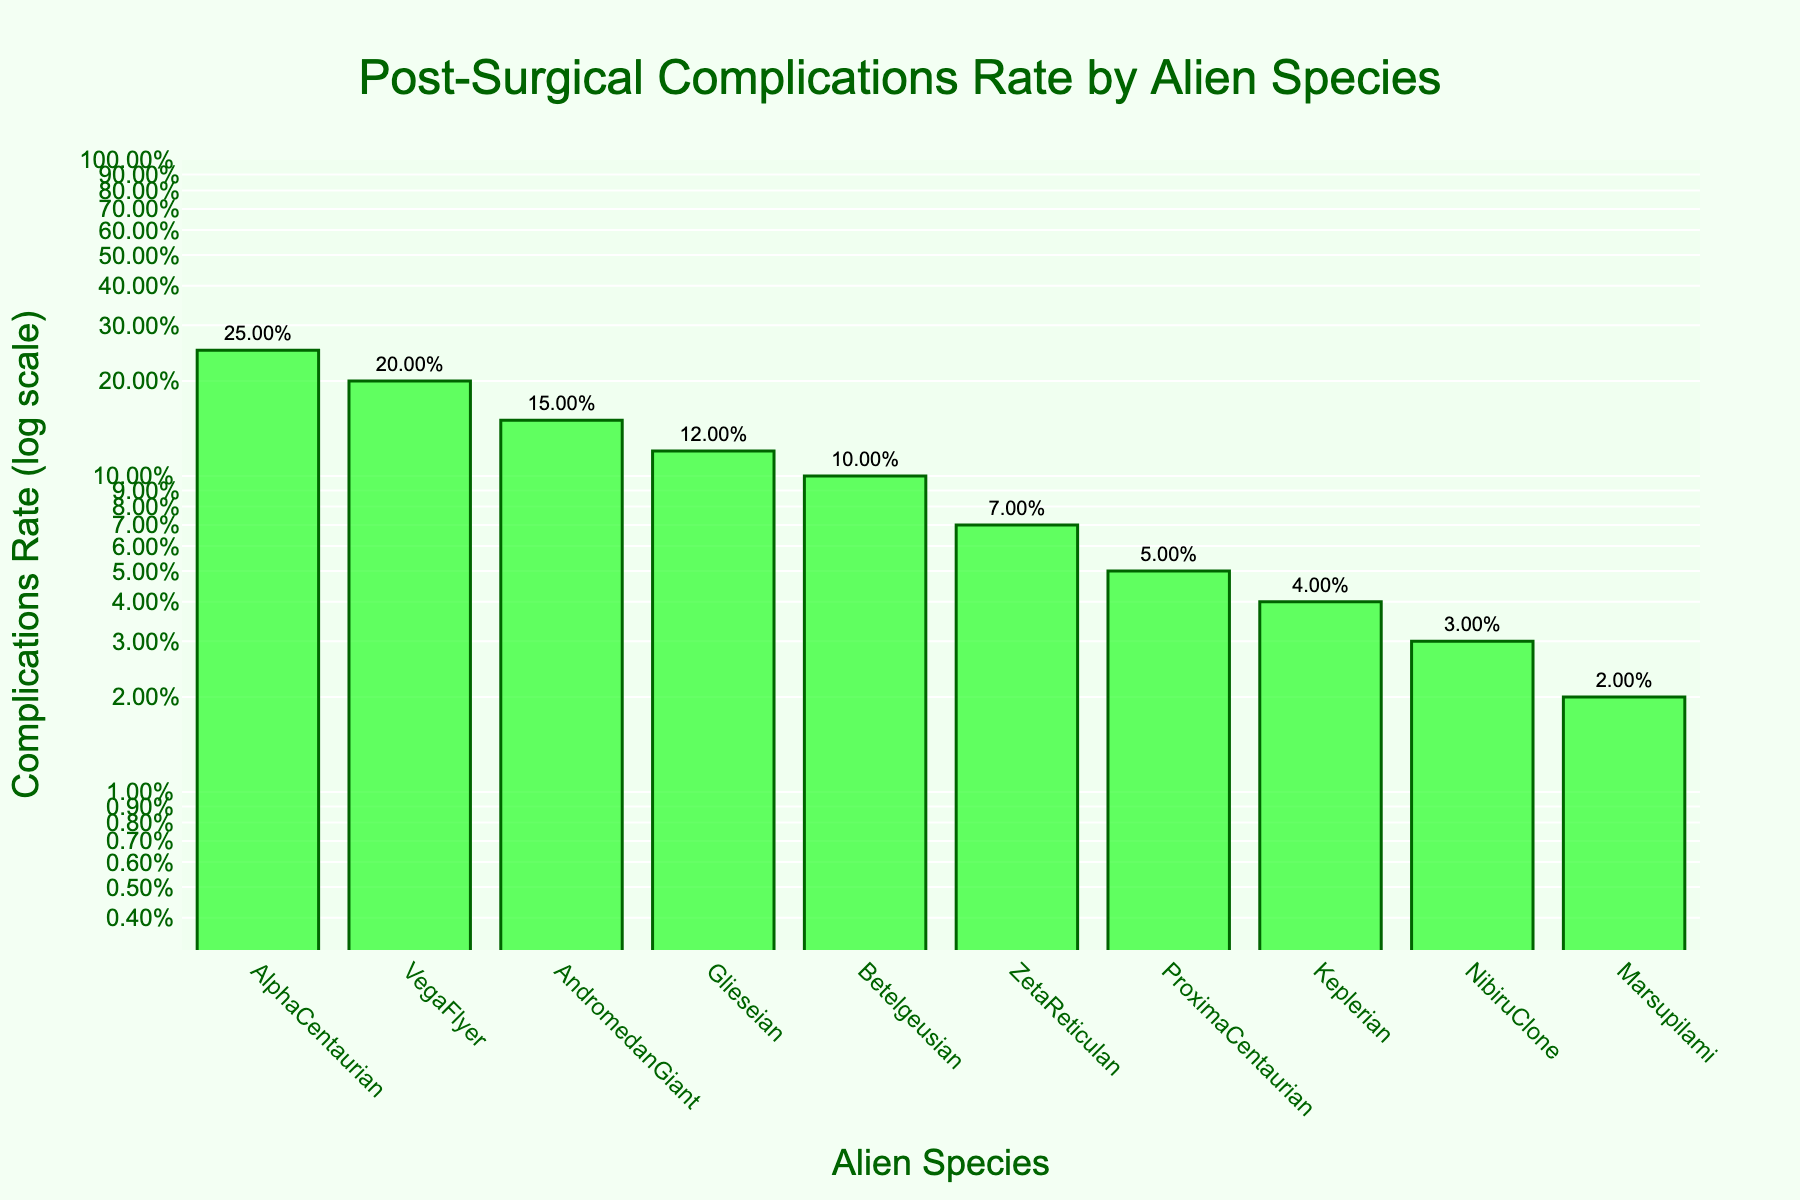How many species in total are plotted on the figure? Count the number of unique species names on the x-axis to determine the total number of species.
Answer: 10 Which alien species has the highest rate of post-surgical complications? Observe the heights of bars on the figure and identify which bar reaches the highest point on the y-axis. The species label under the highest bar represents the species with the highest complication rate.
Answer: AlphaCentaurian What is the complication rate for ZetaReticulan in percentage terms? Look for the bar labeled ZetaReticulan and check the text above the bar to find the complications rate. The answer is in percentage terms next to the species name.
Answer: 7% Which species has a lower complication rate: Keplerian or ProximaCentaurian? Compare the heights of the bars labeled Keplerian and ProximaCentaurian. The bar with the lower height on the y-axis corresponds to the species with the lower complication rate.
Answer: Keplerian What is the approximate difference in complication rate between the highest and lowest species? Identify the highest and lowest bars on the chart. The rate for AlphaCentaurian is approximately 0.25 and for Marsupilami is approximately 0.02. Subtract the complication rates to find the difference.
Answer: 0.23 What is the average complication rate across all species? Sum all the complication rates and divide by the number of species. Rates are: 0.02, 0.15, 0.03, 0.07, 0.25, 0.1, 0.05, 0.12, 0.2, 0.04. Total sum = 1.03. Divide by 10 species.
Answer: 0.103 What is the complexity of the y-axis scale, and why is it used? The y-axis uses a logarithmic scale, which helps in handling a wide range of values and makes it easier to compare smaller values with larger ones on the same plot. This scale compresses the range, making smaller values more discernible.
Answer: Logarithmic scale Which species shows a 15% complication rate according to the figure? Look for the bar with a text label indicating a complication rate of 15%. The species name below this bar will be AndromedanGiant.
Answer: AndromedanGiant How do the complication rates compare between Glieseian and VegaFlyer? Examine and compare the heights of the bars for Glieseian and VegaFlyer. Glieseian has a rate of 12% while VegaFlyer has a rate of 20%.
Answer: VegaFlyer has a higher rate than Glieseian Which species have complication rates above 10% but below 20%? Identify bars with heights that fall within the 10% to 20% complication rate range. The species labels corresponding to these bars are AndromedanGiant, Betelgeusian, and Glieseian.
Answer: AndromedanGiant, Betelgeusian, Glieseian 